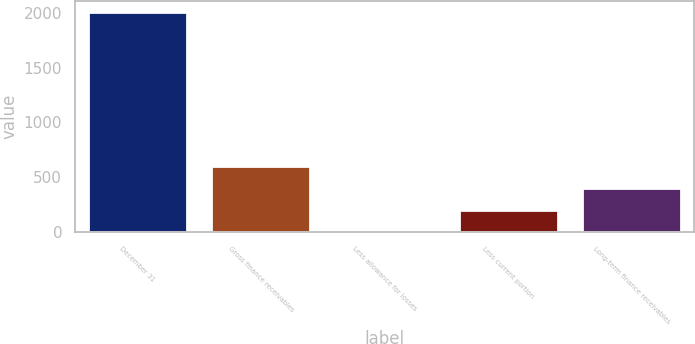Convert chart. <chart><loc_0><loc_0><loc_500><loc_500><bar_chart><fcel>December 31<fcel>Gross finance receivables<fcel>Less allowance for losses<fcel>Less current portion<fcel>Long-term finance receivables<nl><fcel>2007<fcel>605.6<fcel>5<fcel>205.2<fcel>405.4<nl></chart> 